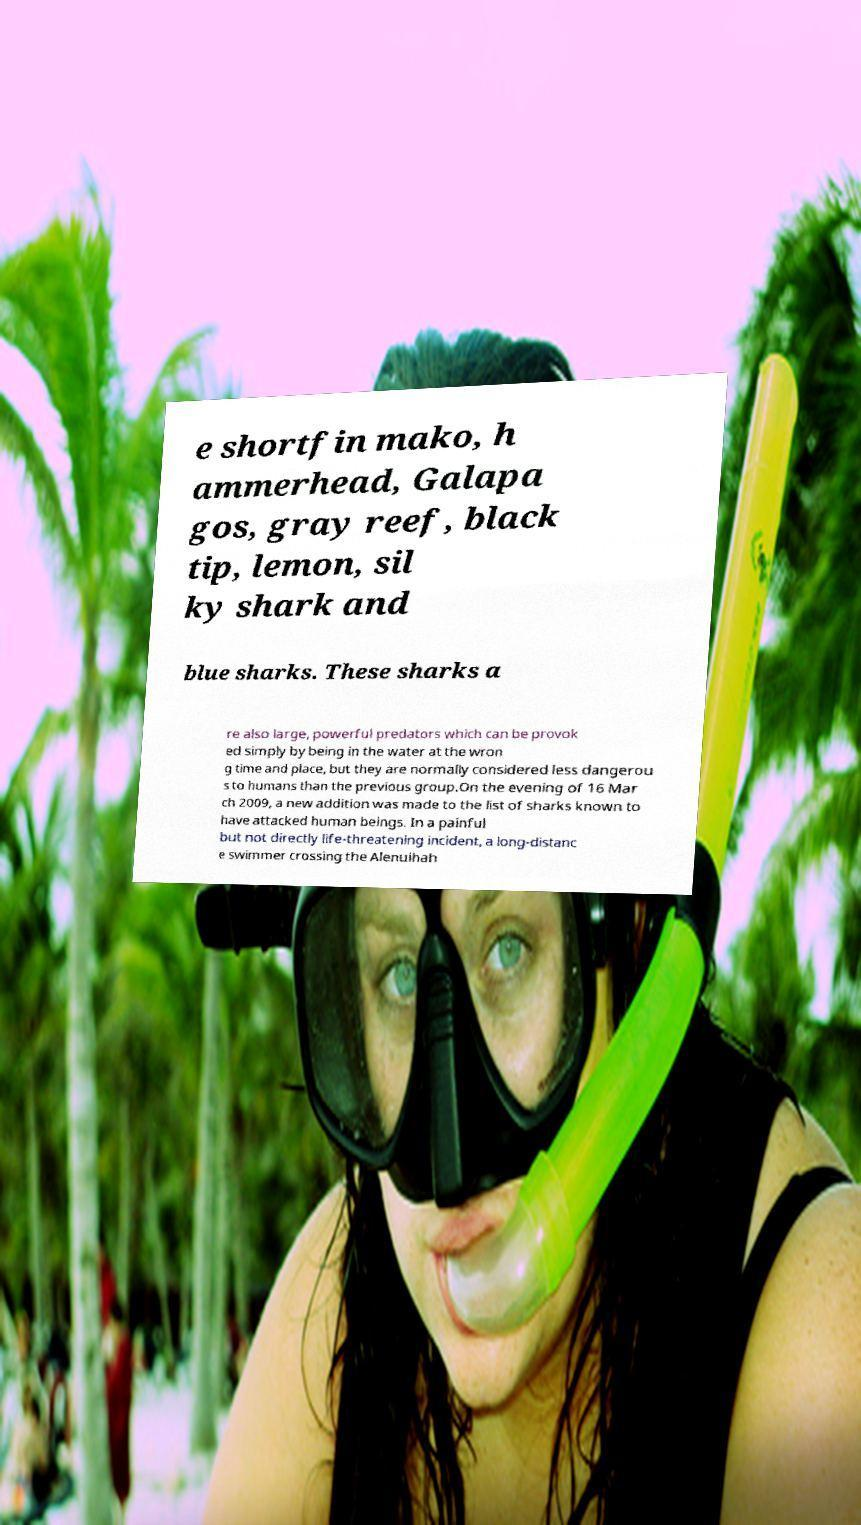Could you assist in decoding the text presented in this image and type it out clearly? e shortfin mako, h ammerhead, Galapa gos, gray reef, black tip, lemon, sil ky shark and blue sharks. These sharks a re also large, powerful predators which can be provok ed simply by being in the water at the wron g time and place, but they are normally considered less dangerou s to humans than the previous group.On the evening of 16 Mar ch 2009, a new addition was made to the list of sharks known to have attacked human beings. In a painful but not directly life-threatening incident, a long-distanc e swimmer crossing the Alenuihah 